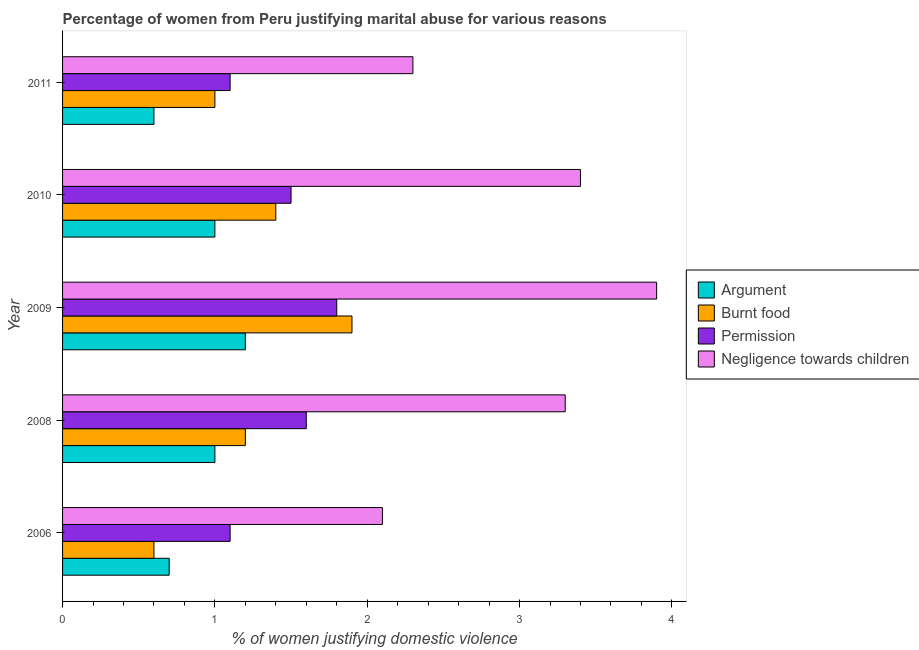Are the number of bars on each tick of the Y-axis equal?
Your response must be concise. Yes. What is the label of the 3rd group of bars from the top?
Give a very brief answer. 2009. In how many cases, is the number of bars for a given year not equal to the number of legend labels?
Provide a succinct answer. 0. What is the percentage of women justifying abuse for going without permission in 2008?
Your answer should be compact. 1.6. Across all years, what is the maximum percentage of women justifying abuse in the case of an argument?
Give a very brief answer. 1.2. Across all years, what is the minimum percentage of women justifying abuse for going without permission?
Your answer should be compact. 1.1. In which year was the percentage of women justifying abuse for showing negligence towards children maximum?
Your answer should be compact. 2009. In which year was the percentage of women justifying abuse in the case of an argument minimum?
Make the answer very short. 2011. What is the total percentage of women justifying abuse for showing negligence towards children in the graph?
Your response must be concise. 15. What is the difference between the percentage of women justifying abuse for burning food in 2010 and that in 2011?
Your answer should be compact. 0.4. What is the difference between the percentage of women justifying abuse for going without permission in 2009 and the percentage of women justifying abuse for showing negligence towards children in 2011?
Offer a terse response. -0.5. What is the average percentage of women justifying abuse for burning food per year?
Your answer should be very brief. 1.22. What is the ratio of the percentage of women justifying abuse for burning food in 2008 to that in 2010?
Provide a short and direct response. 0.86. Is the percentage of women justifying abuse for going without permission in 2006 less than that in 2011?
Make the answer very short. No. Is the difference between the percentage of women justifying abuse for going without permission in 2009 and 2011 greater than the difference between the percentage of women justifying abuse in the case of an argument in 2009 and 2011?
Ensure brevity in your answer.  Yes. What is the difference between the highest and the second highest percentage of women justifying abuse for showing negligence towards children?
Offer a very short reply. 0.5. In how many years, is the percentage of women justifying abuse for going without permission greater than the average percentage of women justifying abuse for going without permission taken over all years?
Your answer should be compact. 3. What does the 3rd bar from the top in 2010 represents?
Offer a very short reply. Burnt food. What does the 2nd bar from the bottom in 2011 represents?
Provide a succinct answer. Burnt food. Is it the case that in every year, the sum of the percentage of women justifying abuse in the case of an argument and percentage of women justifying abuse for burning food is greater than the percentage of women justifying abuse for going without permission?
Keep it short and to the point. Yes. How many years are there in the graph?
Offer a very short reply. 5. Are the values on the major ticks of X-axis written in scientific E-notation?
Offer a terse response. No. Does the graph contain grids?
Your answer should be compact. No. How many legend labels are there?
Make the answer very short. 4. What is the title of the graph?
Provide a succinct answer. Percentage of women from Peru justifying marital abuse for various reasons. Does "Belgium" appear as one of the legend labels in the graph?
Your response must be concise. No. What is the label or title of the X-axis?
Your response must be concise. % of women justifying domestic violence. What is the % of women justifying domestic violence in Permission in 2006?
Make the answer very short. 1.1. What is the % of women justifying domestic violence of Burnt food in 2008?
Provide a short and direct response. 1.2. What is the % of women justifying domestic violence of Argument in 2009?
Your response must be concise. 1.2. What is the % of women justifying domestic violence of Burnt food in 2009?
Ensure brevity in your answer.  1.9. What is the % of women justifying domestic violence of Argument in 2010?
Your answer should be compact. 1. What is the % of women justifying domestic violence in Permission in 2010?
Offer a very short reply. 1.5. What is the % of women justifying domestic violence of Negligence towards children in 2010?
Provide a short and direct response. 3.4. What is the % of women justifying domestic violence in Permission in 2011?
Give a very brief answer. 1.1. Across all years, what is the maximum % of women justifying domestic violence in Permission?
Make the answer very short. 1.8. Across all years, what is the maximum % of women justifying domestic violence of Negligence towards children?
Keep it short and to the point. 3.9. Across all years, what is the minimum % of women justifying domestic violence of Argument?
Offer a terse response. 0.6. Across all years, what is the minimum % of women justifying domestic violence of Burnt food?
Provide a succinct answer. 0.6. Across all years, what is the minimum % of women justifying domestic violence in Permission?
Give a very brief answer. 1.1. Across all years, what is the minimum % of women justifying domestic violence in Negligence towards children?
Make the answer very short. 2.1. What is the total % of women justifying domestic violence of Argument in the graph?
Give a very brief answer. 4.5. What is the total % of women justifying domestic violence of Burnt food in the graph?
Give a very brief answer. 6.1. What is the difference between the % of women justifying domestic violence of Burnt food in 2006 and that in 2008?
Your response must be concise. -0.6. What is the difference between the % of women justifying domestic violence in Permission in 2006 and that in 2008?
Give a very brief answer. -0.5. What is the difference between the % of women justifying domestic violence of Negligence towards children in 2006 and that in 2008?
Give a very brief answer. -1.2. What is the difference between the % of women justifying domestic violence of Argument in 2006 and that in 2010?
Your answer should be very brief. -0.3. What is the difference between the % of women justifying domestic violence in Burnt food in 2006 and that in 2010?
Give a very brief answer. -0.8. What is the difference between the % of women justifying domestic violence of Argument in 2006 and that in 2011?
Your answer should be compact. 0.1. What is the difference between the % of women justifying domestic violence of Permission in 2006 and that in 2011?
Your answer should be compact. 0. What is the difference between the % of women justifying domestic violence of Negligence towards children in 2006 and that in 2011?
Offer a very short reply. -0.2. What is the difference between the % of women justifying domestic violence of Burnt food in 2008 and that in 2009?
Make the answer very short. -0.7. What is the difference between the % of women justifying domestic violence in Permission in 2008 and that in 2009?
Provide a short and direct response. -0.2. What is the difference between the % of women justifying domestic violence of Burnt food in 2008 and that in 2010?
Give a very brief answer. -0.2. What is the difference between the % of women justifying domestic violence in Negligence towards children in 2008 and that in 2010?
Make the answer very short. -0.1. What is the difference between the % of women justifying domestic violence of Argument in 2008 and that in 2011?
Give a very brief answer. 0.4. What is the difference between the % of women justifying domestic violence of Burnt food in 2008 and that in 2011?
Give a very brief answer. 0.2. What is the difference between the % of women justifying domestic violence in Burnt food in 2009 and that in 2010?
Ensure brevity in your answer.  0.5. What is the difference between the % of women justifying domestic violence in Negligence towards children in 2009 and that in 2010?
Make the answer very short. 0.5. What is the difference between the % of women justifying domestic violence in Permission in 2009 and that in 2011?
Provide a succinct answer. 0.7. What is the difference between the % of women justifying domestic violence of Argument in 2010 and that in 2011?
Your answer should be compact. 0.4. What is the difference between the % of women justifying domestic violence in Burnt food in 2010 and that in 2011?
Keep it short and to the point. 0.4. What is the difference between the % of women justifying domestic violence in Argument in 2006 and the % of women justifying domestic violence in Permission in 2008?
Your response must be concise. -0.9. What is the difference between the % of women justifying domestic violence of Burnt food in 2006 and the % of women justifying domestic violence of Negligence towards children in 2008?
Your response must be concise. -2.7. What is the difference between the % of women justifying domestic violence of Permission in 2006 and the % of women justifying domestic violence of Negligence towards children in 2008?
Give a very brief answer. -2.2. What is the difference between the % of women justifying domestic violence in Argument in 2006 and the % of women justifying domestic violence in Negligence towards children in 2009?
Make the answer very short. -3.2. What is the difference between the % of women justifying domestic violence of Burnt food in 2006 and the % of women justifying domestic violence of Permission in 2009?
Ensure brevity in your answer.  -1.2. What is the difference between the % of women justifying domestic violence in Burnt food in 2006 and the % of women justifying domestic violence in Negligence towards children in 2009?
Your response must be concise. -3.3. What is the difference between the % of women justifying domestic violence in Permission in 2006 and the % of women justifying domestic violence in Negligence towards children in 2009?
Provide a short and direct response. -2.8. What is the difference between the % of women justifying domestic violence of Argument in 2006 and the % of women justifying domestic violence of Burnt food in 2010?
Make the answer very short. -0.7. What is the difference between the % of women justifying domestic violence in Argument in 2006 and the % of women justifying domestic violence in Permission in 2010?
Your answer should be compact. -0.8. What is the difference between the % of women justifying domestic violence in Argument in 2006 and the % of women justifying domestic violence in Negligence towards children in 2010?
Provide a short and direct response. -2.7. What is the difference between the % of women justifying domestic violence in Burnt food in 2006 and the % of women justifying domestic violence in Permission in 2010?
Ensure brevity in your answer.  -0.9. What is the difference between the % of women justifying domestic violence in Burnt food in 2006 and the % of women justifying domestic violence in Negligence towards children in 2010?
Keep it short and to the point. -2.8. What is the difference between the % of women justifying domestic violence of Burnt food in 2006 and the % of women justifying domestic violence of Permission in 2011?
Give a very brief answer. -0.5. What is the difference between the % of women justifying domestic violence of Argument in 2008 and the % of women justifying domestic violence of Negligence towards children in 2009?
Your answer should be very brief. -2.9. What is the difference between the % of women justifying domestic violence of Argument in 2008 and the % of women justifying domestic violence of Permission in 2010?
Your answer should be compact. -0.5. What is the difference between the % of women justifying domestic violence in Argument in 2008 and the % of women justifying domestic violence in Negligence towards children in 2010?
Your answer should be very brief. -2.4. What is the difference between the % of women justifying domestic violence of Burnt food in 2008 and the % of women justifying domestic violence of Permission in 2010?
Provide a short and direct response. -0.3. What is the difference between the % of women justifying domestic violence of Argument in 2008 and the % of women justifying domestic violence of Burnt food in 2011?
Make the answer very short. 0. What is the difference between the % of women justifying domestic violence of Argument in 2008 and the % of women justifying domestic violence of Permission in 2011?
Keep it short and to the point. -0.1. What is the difference between the % of women justifying domestic violence in Argument in 2008 and the % of women justifying domestic violence in Negligence towards children in 2011?
Give a very brief answer. -1.3. What is the difference between the % of women justifying domestic violence in Burnt food in 2008 and the % of women justifying domestic violence in Permission in 2011?
Provide a short and direct response. 0.1. What is the difference between the % of women justifying domestic violence of Burnt food in 2009 and the % of women justifying domestic violence of Negligence towards children in 2010?
Your answer should be very brief. -1.5. What is the difference between the % of women justifying domestic violence of Permission in 2009 and the % of women justifying domestic violence of Negligence towards children in 2010?
Provide a succinct answer. -1.6. What is the difference between the % of women justifying domestic violence of Argument in 2009 and the % of women justifying domestic violence of Burnt food in 2011?
Keep it short and to the point. 0.2. What is the difference between the % of women justifying domestic violence of Argument in 2009 and the % of women justifying domestic violence of Negligence towards children in 2011?
Your response must be concise. -1.1. What is the difference between the % of women justifying domestic violence of Permission in 2009 and the % of women justifying domestic violence of Negligence towards children in 2011?
Offer a terse response. -0.5. What is the difference between the % of women justifying domestic violence of Argument in 2010 and the % of women justifying domestic violence of Burnt food in 2011?
Provide a succinct answer. 0. What is the difference between the % of women justifying domestic violence of Burnt food in 2010 and the % of women justifying domestic violence of Permission in 2011?
Ensure brevity in your answer.  0.3. What is the difference between the % of women justifying domestic violence of Permission in 2010 and the % of women justifying domestic violence of Negligence towards children in 2011?
Give a very brief answer. -0.8. What is the average % of women justifying domestic violence in Burnt food per year?
Provide a succinct answer. 1.22. What is the average % of women justifying domestic violence of Permission per year?
Keep it short and to the point. 1.42. In the year 2006, what is the difference between the % of women justifying domestic violence in Argument and % of women justifying domestic violence in Burnt food?
Your answer should be very brief. 0.1. In the year 2006, what is the difference between the % of women justifying domestic violence of Argument and % of women justifying domestic violence of Negligence towards children?
Offer a terse response. -1.4. In the year 2006, what is the difference between the % of women justifying domestic violence of Burnt food and % of women justifying domestic violence of Negligence towards children?
Your response must be concise. -1.5. In the year 2006, what is the difference between the % of women justifying domestic violence of Permission and % of women justifying domestic violence of Negligence towards children?
Ensure brevity in your answer.  -1. In the year 2008, what is the difference between the % of women justifying domestic violence of Argument and % of women justifying domestic violence of Negligence towards children?
Your response must be concise. -2.3. In the year 2008, what is the difference between the % of women justifying domestic violence of Burnt food and % of women justifying domestic violence of Permission?
Provide a succinct answer. -0.4. In the year 2008, what is the difference between the % of women justifying domestic violence of Burnt food and % of women justifying domestic violence of Negligence towards children?
Your response must be concise. -2.1. In the year 2008, what is the difference between the % of women justifying domestic violence in Permission and % of women justifying domestic violence in Negligence towards children?
Provide a short and direct response. -1.7. In the year 2009, what is the difference between the % of women justifying domestic violence of Argument and % of women justifying domestic violence of Burnt food?
Your response must be concise. -0.7. In the year 2009, what is the difference between the % of women justifying domestic violence in Permission and % of women justifying domestic violence in Negligence towards children?
Provide a succinct answer. -2.1. In the year 2010, what is the difference between the % of women justifying domestic violence of Argument and % of women justifying domestic violence of Permission?
Your answer should be very brief. -0.5. In the year 2010, what is the difference between the % of women justifying domestic violence of Argument and % of women justifying domestic violence of Negligence towards children?
Ensure brevity in your answer.  -2.4. In the year 2011, what is the difference between the % of women justifying domestic violence of Argument and % of women justifying domestic violence of Negligence towards children?
Your answer should be very brief. -1.7. In the year 2011, what is the difference between the % of women justifying domestic violence in Burnt food and % of women justifying domestic violence in Permission?
Your answer should be compact. -0.1. In the year 2011, what is the difference between the % of women justifying domestic violence of Permission and % of women justifying domestic violence of Negligence towards children?
Your answer should be very brief. -1.2. What is the ratio of the % of women justifying domestic violence in Permission in 2006 to that in 2008?
Your answer should be compact. 0.69. What is the ratio of the % of women justifying domestic violence in Negligence towards children in 2006 to that in 2008?
Offer a very short reply. 0.64. What is the ratio of the % of women justifying domestic violence of Argument in 2006 to that in 2009?
Provide a short and direct response. 0.58. What is the ratio of the % of women justifying domestic violence in Burnt food in 2006 to that in 2009?
Ensure brevity in your answer.  0.32. What is the ratio of the % of women justifying domestic violence in Permission in 2006 to that in 2009?
Offer a terse response. 0.61. What is the ratio of the % of women justifying domestic violence of Negligence towards children in 2006 to that in 2009?
Your answer should be very brief. 0.54. What is the ratio of the % of women justifying domestic violence in Burnt food in 2006 to that in 2010?
Give a very brief answer. 0.43. What is the ratio of the % of women justifying domestic violence in Permission in 2006 to that in 2010?
Offer a very short reply. 0.73. What is the ratio of the % of women justifying domestic violence of Negligence towards children in 2006 to that in 2010?
Your answer should be very brief. 0.62. What is the ratio of the % of women justifying domestic violence in Argument in 2006 to that in 2011?
Your answer should be compact. 1.17. What is the ratio of the % of women justifying domestic violence in Permission in 2006 to that in 2011?
Offer a terse response. 1. What is the ratio of the % of women justifying domestic violence in Burnt food in 2008 to that in 2009?
Ensure brevity in your answer.  0.63. What is the ratio of the % of women justifying domestic violence in Permission in 2008 to that in 2009?
Your answer should be compact. 0.89. What is the ratio of the % of women justifying domestic violence in Negligence towards children in 2008 to that in 2009?
Provide a short and direct response. 0.85. What is the ratio of the % of women justifying domestic violence in Argument in 2008 to that in 2010?
Provide a succinct answer. 1. What is the ratio of the % of women justifying domestic violence of Permission in 2008 to that in 2010?
Make the answer very short. 1.07. What is the ratio of the % of women justifying domestic violence of Negligence towards children in 2008 to that in 2010?
Make the answer very short. 0.97. What is the ratio of the % of women justifying domestic violence in Argument in 2008 to that in 2011?
Give a very brief answer. 1.67. What is the ratio of the % of women justifying domestic violence of Burnt food in 2008 to that in 2011?
Provide a succinct answer. 1.2. What is the ratio of the % of women justifying domestic violence in Permission in 2008 to that in 2011?
Ensure brevity in your answer.  1.45. What is the ratio of the % of women justifying domestic violence in Negligence towards children in 2008 to that in 2011?
Keep it short and to the point. 1.43. What is the ratio of the % of women justifying domestic violence in Burnt food in 2009 to that in 2010?
Ensure brevity in your answer.  1.36. What is the ratio of the % of women justifying domestic violence of Permission in 2009 to that in 2010?
Keep it short and to the point. 1.2. What is the ratio of the % of women justifying domestic violence in Negligence towards children in 2009 to that in 2010?
Provide a succinct answer. 1.15. What is the ratio of the % of women justifying domestic violence of Argument in 2009 to that in 2011?
Offer a terse response. 2. What is the ratio of the % of women justifying domestic violence in Permission in 2009 to that in 2011?
Provide a short and direct response. 1.64. What is the ratio of the % of women justifying domestic violence in Negligence towards children in 2009 to that in 2011?
Provide a succinct answer. 1.7. What is the ratio of the % of women justifying domestic violence in Argument in 2010 to that in 2011?
Offer a very short reply. 1.67. What is the ratio of the % of women justifying domestic violence in Burnt food in 2010 to that in 2011?
Your answer should be compact. 1.4. What is the ratio of the % of women justifying domestic violence of Permission in 2010 to that in 2011?
Keep it short and to the point. 1.36. What is the ratio of the % of women justifying domestic violence of Negligence towards children in 2010 to that in 2011?
Provide a succinct answer. 1.48. What is the difference between the highest and the second highest % of women justifying domestic violence in Argument?
Your answer should be very brief. 0.2. What is the difference between the highest and the lowest % of women justifying domestic violence of Burnt food?
Provide a succinct answer. 1.3. What is the difference between the highest and the lowest % of women justifying domestic violence in Permission?
Offer a very short reply. 0.7. What is the difference between the highest and the lowest % of women justifying domestic violence in Negligence towards children?
Your answer should be very brief. 1.8. 